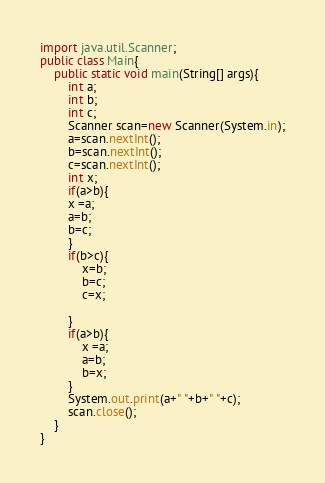<code> <loc_0><loc_0><loc_500><loc_500><_Java_>import java.util.Scanner;
public class Main{
	public static void main(String[] args){
		int a;
		int b;
		int c;
		Scanner scan=new Scanner(System.in);
		a=scan.nextInt();
		b=scan.nextInt();
		c=scan.nextInt();
		int x;
		if(a>b){
		x =a;
		a=b;
		b=c;
		}
		if(b>c){
			x=b;
			b=c;
			c=x;
			
		}
		if(a>b){
			x =a;
			a=b;
			b=x;	
		}
		System.out.print(a+" "+b+" "+c);
		scan.close();
	}
}
</code> 